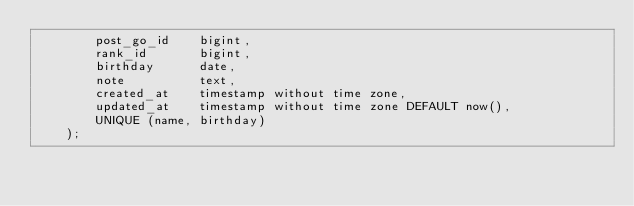<code> <loc_0><loc_0><loc_500><loc_500><_SQL_>        post_go_id    bigint,
        rank_id       bigint,
        birthday      date,
        note          text,
        created_at    timestamp without time zone,
        updated_at    timestamp without time zone DEFAULT now(),
        UNIQUE (name, birthday)
    );</code> 